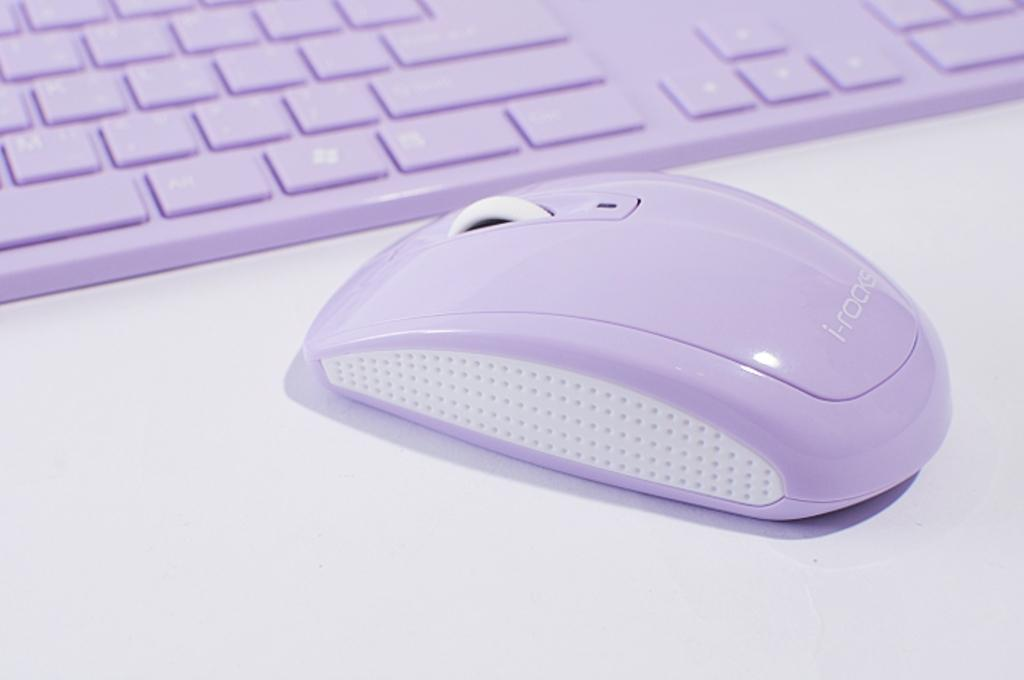What type of input device is visible in the image? There is a computer mouse in the image. What other input device is present in the image? There is a keyboard in the image. What color is the surface the computer mouse and keyboard are on? The surface is white. Is there a cart with a dog inside the tent in the image? There is no cart, dog, or tent present in the image. 